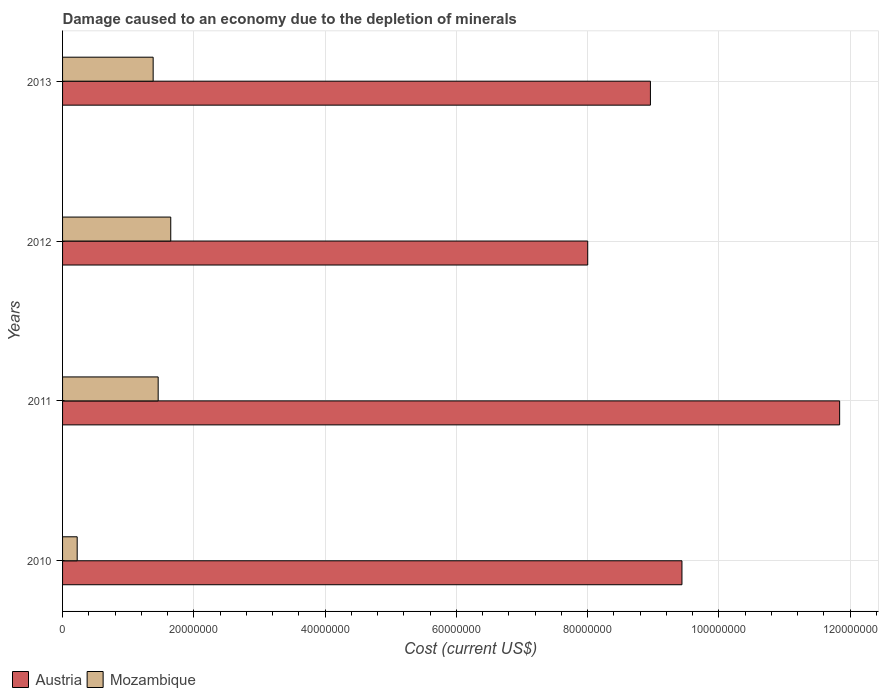Are the number of bars per tick equal to the number of legend labels?
Your answer should be very brief. Yes. Are the number of bars on each tick of the Y-axis equal?
Offer a very short reply. Yes. How many bars are there on the 3rd tick from the top?
Your answer should be very brief. 2. How many bars are there on the 4th tick from the bottom?
Ensure brevity in your answer.  2. What is the cost of damage caused due to the depletion of minerals in Mozambique in 2013?
Give a very brief answer. 1.38e+07. Across all years, what is the maximum cost of damage caused due to the depletion of minerals in Mozambique?
Your answer should be very brief. 1.65e+07. Across all years, what is the minimum cost of damage caused due to the depletion of minerals in Austria?
Offer a terse response. 8.00e+07. In which year was the cost of damage caused due to the depletion of minerals in Austria maximum?
Keep it short and to the point. 2011. In which year was the cost of damage caused due to the depletion of minerals in Austria minimum?
Make the answer very short. 2012. What is the total cost of damage caused due to the depletion of minerals in Austria in the graph?
Your response must be concise. 3.82e+08. What is the difference between the cost of damage caused due to the depletion of minerals in Austria in 2010 and that in 2012?
Make the answer very short. 1.44e+07. What is the difference between the cost of damage caused due to the depletion of minerals in Mozambique in 2011 and the cost of damage caused due to the depletion of minerals in Austria in 2012?
Keep it short and to the point. -6.54e+07. What is the average cost of damage caused due to the depletion of minerals in Mozambique per year?
Provide a succinct answer. 1.18e+07. In the year 2013, what is the difference between the cost of damage caused due to the depletion of minerals in Mozambique and cost of damage caused due to the depletion of minerals in Austria?
Provide a short and direct response. -7.58e+07. What is the ratio of the cost of damage caused due to the depletion of minerals in Austria in 2010 to that in 2013?
Your answer should be compact. 1.05. Is the cost of damage caused due to the depletion of minerals in Mozambique in 2010 less than that in 2013?
Provide a short and direct response. Yes. Is the difference between the cost of damage caused due to the depletion of minerals in Mozambique in 2011 and 2013 greater than the difference between the cost of damage caused due to the depletion of minerals in Austria in 2011 and 2013?
Ensure brevity in your answer.  No. What is the difference between the highest and the second highest cost of damage caused due to the depletion of minerals in Austria?
Offer a terse response. 2.40e+07. What is the difference between the highest and the lowest cost of damage caused due to the depletion of minerals in Mozambique?
Provide a succinct answer. 1.43e+07. What does the 1st bar from the top in 2013 represents?
Offer a terse response. Mozambique. How many bars are there?
Provide a succinct answer. 8. Are all the bars in the graph horizontal?
Provide a succinct answer. Yes. How many years are there in the graph?
Keep it short and to the point. 4. Are the values on the major ticks of X-axis written in scientific E-notation?
Make the answer very short. No. Does the graph contain grids?
Ensure brevity in your answer.  Yes. Where does the legend appear in the graph?
Offer a terse response. Bottom left. How many legend labels are there?
Make the answer very short. 2. How are the legend labels stacked?
Provide a succinct answer. Horizontal. What is the title of the graph?
Ensure brevity in your answer.  Damage caused to an economy due to the depletion of minerals. What is the label or title of the X-axis?
Your answer should be very brief. Cost (current US$). What is the label or title of the Y-axis?
Provide a short and direct response. Years. What is the Cost (current US$) of Austria in 2010?
Offer a very short reply. 9.44e+07. What is the Cost (current US$) of Mozambique in 2010?
Offer a very short reply. 2.23e+06. What is the Cost (current US$) in Austria in 2011?
Your response must be concise. 1.18e+08. What is the Cost (current US$) in Mozambique in 2011?
Provide a short and direct response. 1.46e+07. What is the Cost (current US$) in Austria in 2012?
Your response must be concise. 8.00e+07. What is the Cost (current US$) in Mozambique in 2012?
Your response must be concise. 1.65e+07. What is the Cost (current US$) of Austria in 2013?
Ensure brevity in your answer.  8.96e+07. What is the Cost (current US$) in Mozambique in 2013?
Make the answer very short. 1.38e+07. Across all years, what is the maximum Cost (current US$) of Austria?
Your response must be concise. 1.18e+08. Across all years, what is the maximum Cost (current US$) of Mozambique?
Provide a succinct answer. 1.65e+07. Across all years, what is the minimum Cost (current US$) of Austria?
Your answer should be compact. 8.00e+07. Across all years, what is the minimum Cost (current US$) of Mozambique?
Provide a succinct answer. 2.23e+06. What is the total Cost (current US$) of Austria in the graph?
Offer a terse response. 3.82e+08. What is the total Cost (current US$) of Mozambique in the graph?
Offer a terse response. 4.71e+07. What is the difference between the Cost (current US$) in Austria in 2010 and that in 2011?
Keep it short and to the point. -2.40e+07. What is the difference between the Cost (current US$) in Mozambique in 2010 and that in 2011?
Offer a terse response. -1.23e+07. What is the difference between the Cost (current US$) in Austria in 2010 and that in 2012?
Your answer should be compact. 1.44e+07. What is the difference between the Cost (current US$) in Mozambique in 2010 and that in 2012?
Offer a very short reply. -1.43e+07. What is the difference between the Cost (current US$) in Austria in 2010 and that in 2013?
Keep it short and to the point. 4.80e+06. What is the difference between the Cost (current US$) in Mozambique in 2010 and that in 2013?
Offer a terse response. -1.16e+07. What is the difference between the Cost (current US$) in Austria in 2011 and that in 2012?
Your answer should be compact. 3.84e+07. What is the difference between the Cost (current US$) of Mozambique in 2011 and that in 2012?
Provide a short and direct response. -1.92e+06. What is the difference between the Cost (current US$) in Austria in 2011 and that in 2013?
Your answer should be very brief. 2.88e+07. What is the difference between the Cost (current US$) of Mozambique in 2011 and that in 2013?
Make the answer very short. 7.62e+05. What is the difference between the Cost (current US$) of Austria in 2012 and that in 2013?
Offer a very short reply. -9.55e+06. What is the difference between the Cost (current US$) in Mozambique in 2012 and that in 2013?
Make the answer very short. 2.68e+06. What is the difference between the Cost (current US$) of Austria in 2010 and the Cost (current US$) of Mozambique in 2011?
Provide a short and direct response. 7.98e+07. What is the difference between the Cost (current US$) of Austria in 2010 and the Cost (current US$) of Mozambique in 2012?
Your answer should be compact. 7.79e+07. What is the difference between the Cost (current US$) in Austria in 2010 and the Cost (current US$) in Mozambique in 2013?
Your response must be concise. 8.06e+07. What is the difference between the Cost (current US$) of Austria in 2011 and the Cost (current US$) of Mozambique in 2012?
Offer a terse response. 1.02e+08. What is the difference between the Cost (current US$) in Austria in 2011 and the Cost (current US$) in Mozambique in 2013?
Offer a very short reply. 1.05e+08. What is the difference between the Cost (current US$) of Austria in 2012 and the Cost (current US$) of Mozambique in 2013?
Provide a succinct answer. 6.62e+07. What is the average Cost (current US$) in Austria per year?
Provide a succinct answer. 9.56e+07. What is the average Cost (current US$) in Mozambique per year?
Offer a terse response. 1.18e+07. In the year 2010, what is the difference between the Cost (current US$) in Austria and Cost (current US$) in Mozambique?
Provide a succinct answer. 9.21e+07. In the year 2011, what is the difference between the Cost (current US$) of Austria and Cost (current US$) of Mozambique?
Provide a succinct answer. 1.04e+08. In the year 2012, what is the difference between the Cost (current US$) of Austria and Cost (current US$) of Mozambique?
Provide a short and direct response. 6.35e+07. In the year 2013, what is the difference between the Cost (current US$) of Austria and Cost (current US$) of Mozambique?
Your response must be concise. 7.58e+07. What is the ratio of the Cost (current US$) of Austria in 2010 to that in 2011?
Keep it short and to the point. 0.8. What is the ratio of the Cost (current US$) of Mozambique in 2010 to that in 2011?
Your answer should be compact. 0.15. What is the ratio of the Cost (current US$) of Austria in 2010 to that in 2012?
Keep it short and to the point. 1.18. What is the ratio of the Cost (current US$) in Mozambique in 2010 to that in 2012?
Keep it short and to the point. 0.14. What is the ratio of the Cost (current US$) in Austria in 2010 to that in 2013?
Offer a very short reply. 1.05. What is the ratio of the Cost (current US$) in Mozambique in 2010 to that in 2013?
Ensure brevity in your answer.  0.16. What is the ratio of the Cost (current US$) of Austria in 2011 to that in 2012?
Provide a succinct answer. 1.48. What is the ratio of the Cost (current US$) of Mozambique in 2011 to that in 2012?
Ensure brevity in your answer.  0.88. What is the ratio of the Cost (current US$) of Austria in 2011 to that in 2013?
Offer a terse response. 1.32. What is the ratio of the Cost (current US$) of Mozambique in 2011 to that in 2013?
Give a very brief answer. 1.06. What is the ratio of the Cost (current US$) of Austria in 2012 to that in 2013?
Provide a succinct answer. 0.89. What is the ratio of the Cost (current US$) in Mozambique in 2012 to that in 2013?
Give a very brief answer. 1.19. What is the difference between the highest and the second highest Cost (current US$) in Austria?
Offer a terse response. 2.40e+07. What is the difference between the highest and the second highest Cost (current US$) in Mozambique?
Make the answer very short. 1.92e+06. What is the difference between the highest and the lowest Cost (current US$) of Austria?
Keep it short and to the point. 3.84e+07. What is the difference between the highest and the lowest Cost (current US$) of Mozambique?
Offer a terse response. 1.43e+07. 